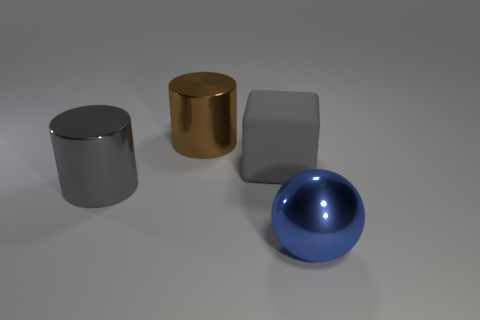Add 2 large gray matte things. How many objects exist? 6 Subtract all brown cylinders. How many cylinders are left? 1 Subtract all balls. How many objects are left? 3 Subtract 1 blocks. How many blocks are left? 0 Subtract all yellow blocks. Subtract all green cylinders. How many blocks are left? 1 Subtract all purple spheres. How many purple cylinders are left? 0 Subtract all rubber things. Subtract all big blocks. How many objects are left? 2 Add 2 large gray cylinders. How many large gray cylinders are left? 3 Add 4 big yellow blocks. How many big yellow blocks exist? 4 Subtract 0 cyan spheres. How many objects are left? 4 